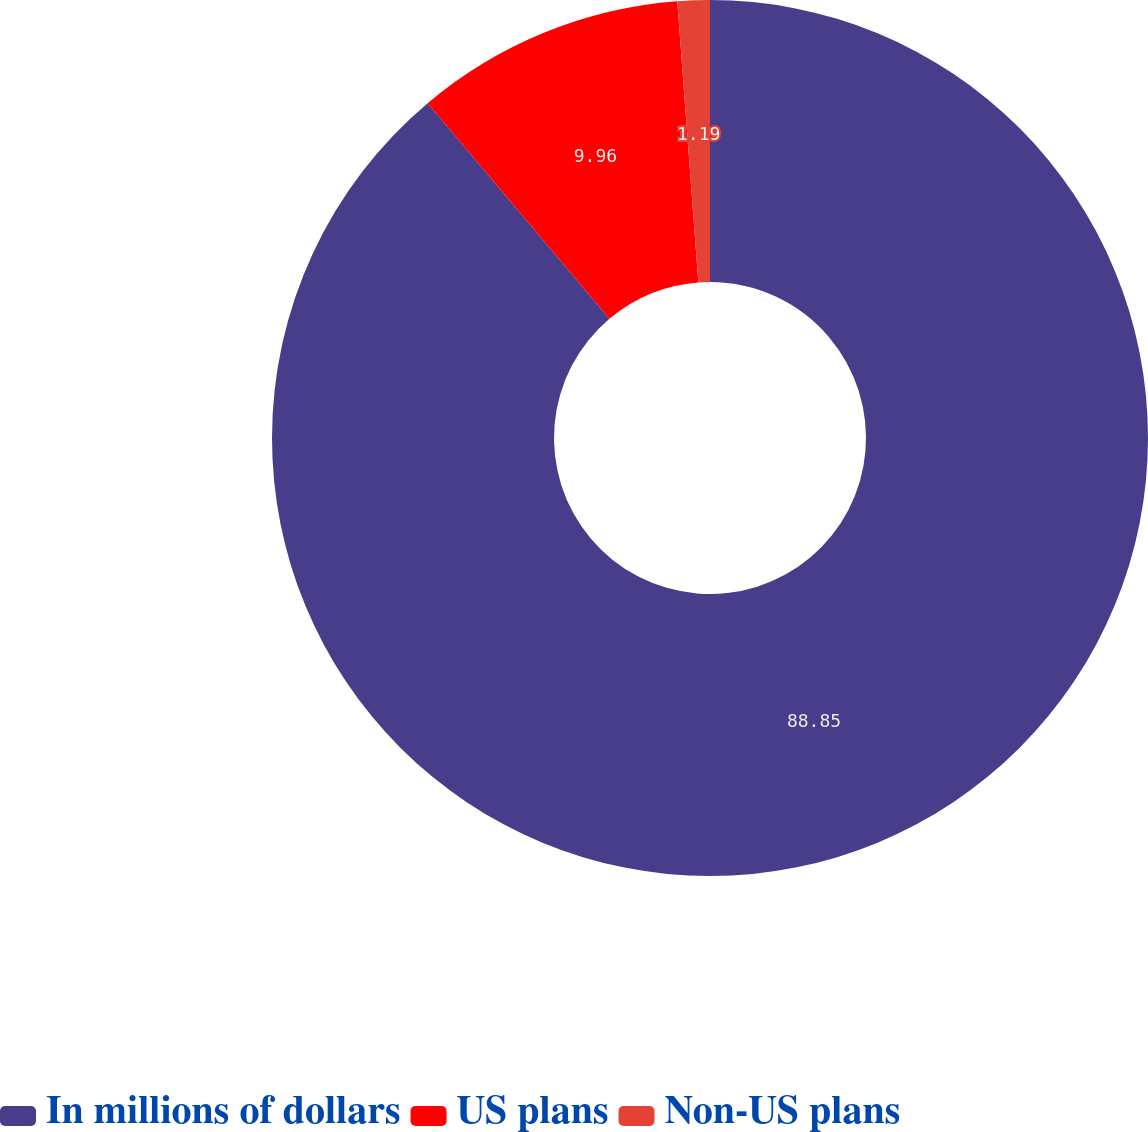Convert chart to OTSL. <chart><loc_0><loc_0><loc_500><loc_500><pie_chart><fcel>In millions of dollars<fcel>US plans<fcel>Non-US plans<nl><fcel>88.85%<fcel>9.96%<fcel>1.19%<nl></chart> 